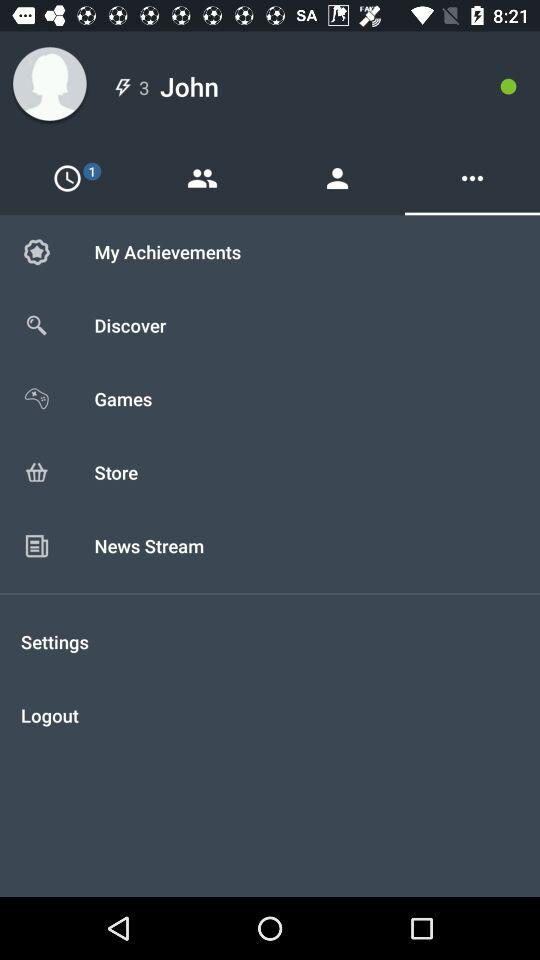What is the name of the user? The name of the user is John. 